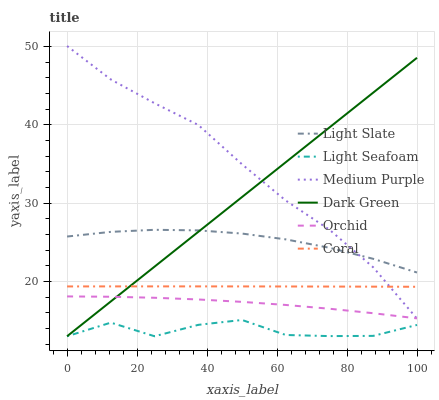Does Light Seafoam have the minimum area under the curve?
Answer yes or no. Yes. Does Medium Purple have the maximum area under the curve?
Answer yes or no. Yes. Does Coral have the minimum area under the curve?
Answer yes or no. No. Does Coral have the maximum area under the curve?
Answer yes or no. No. Is Dark Green the smoothest?
Answer yes or no. Yes. Is Light Seafoam the roughest?
Answer yes or no. Yes. Is Coral the smoothest?
Answer yes or no. No. Is Coral the roughest?
Answer yes or no. No. Does Dark Green have the lowest value?
Answer yes or no. Yes. Does Coral have the lowest value?
Answer yes or no. No. Does Medium Purple have the highest value?
Answer yes or no. Yes. Does Coral have the highest value?
Answer yes or no. No. Is Light Seafoam less than Orchid?
Answer yes or no. Yes. Is Light Slate greater than Coral?
Answer yes or no. Yes. Does Coral intersect Dark Green?
Answer yes or no. Yes. Is Coral less than Dark Green?
Answer yes or no. No. Is Coral greater than Dark Green?
Answer yes or no. No. Does Light Seafoam intersect Orchid?
Answer yes or no. No. 